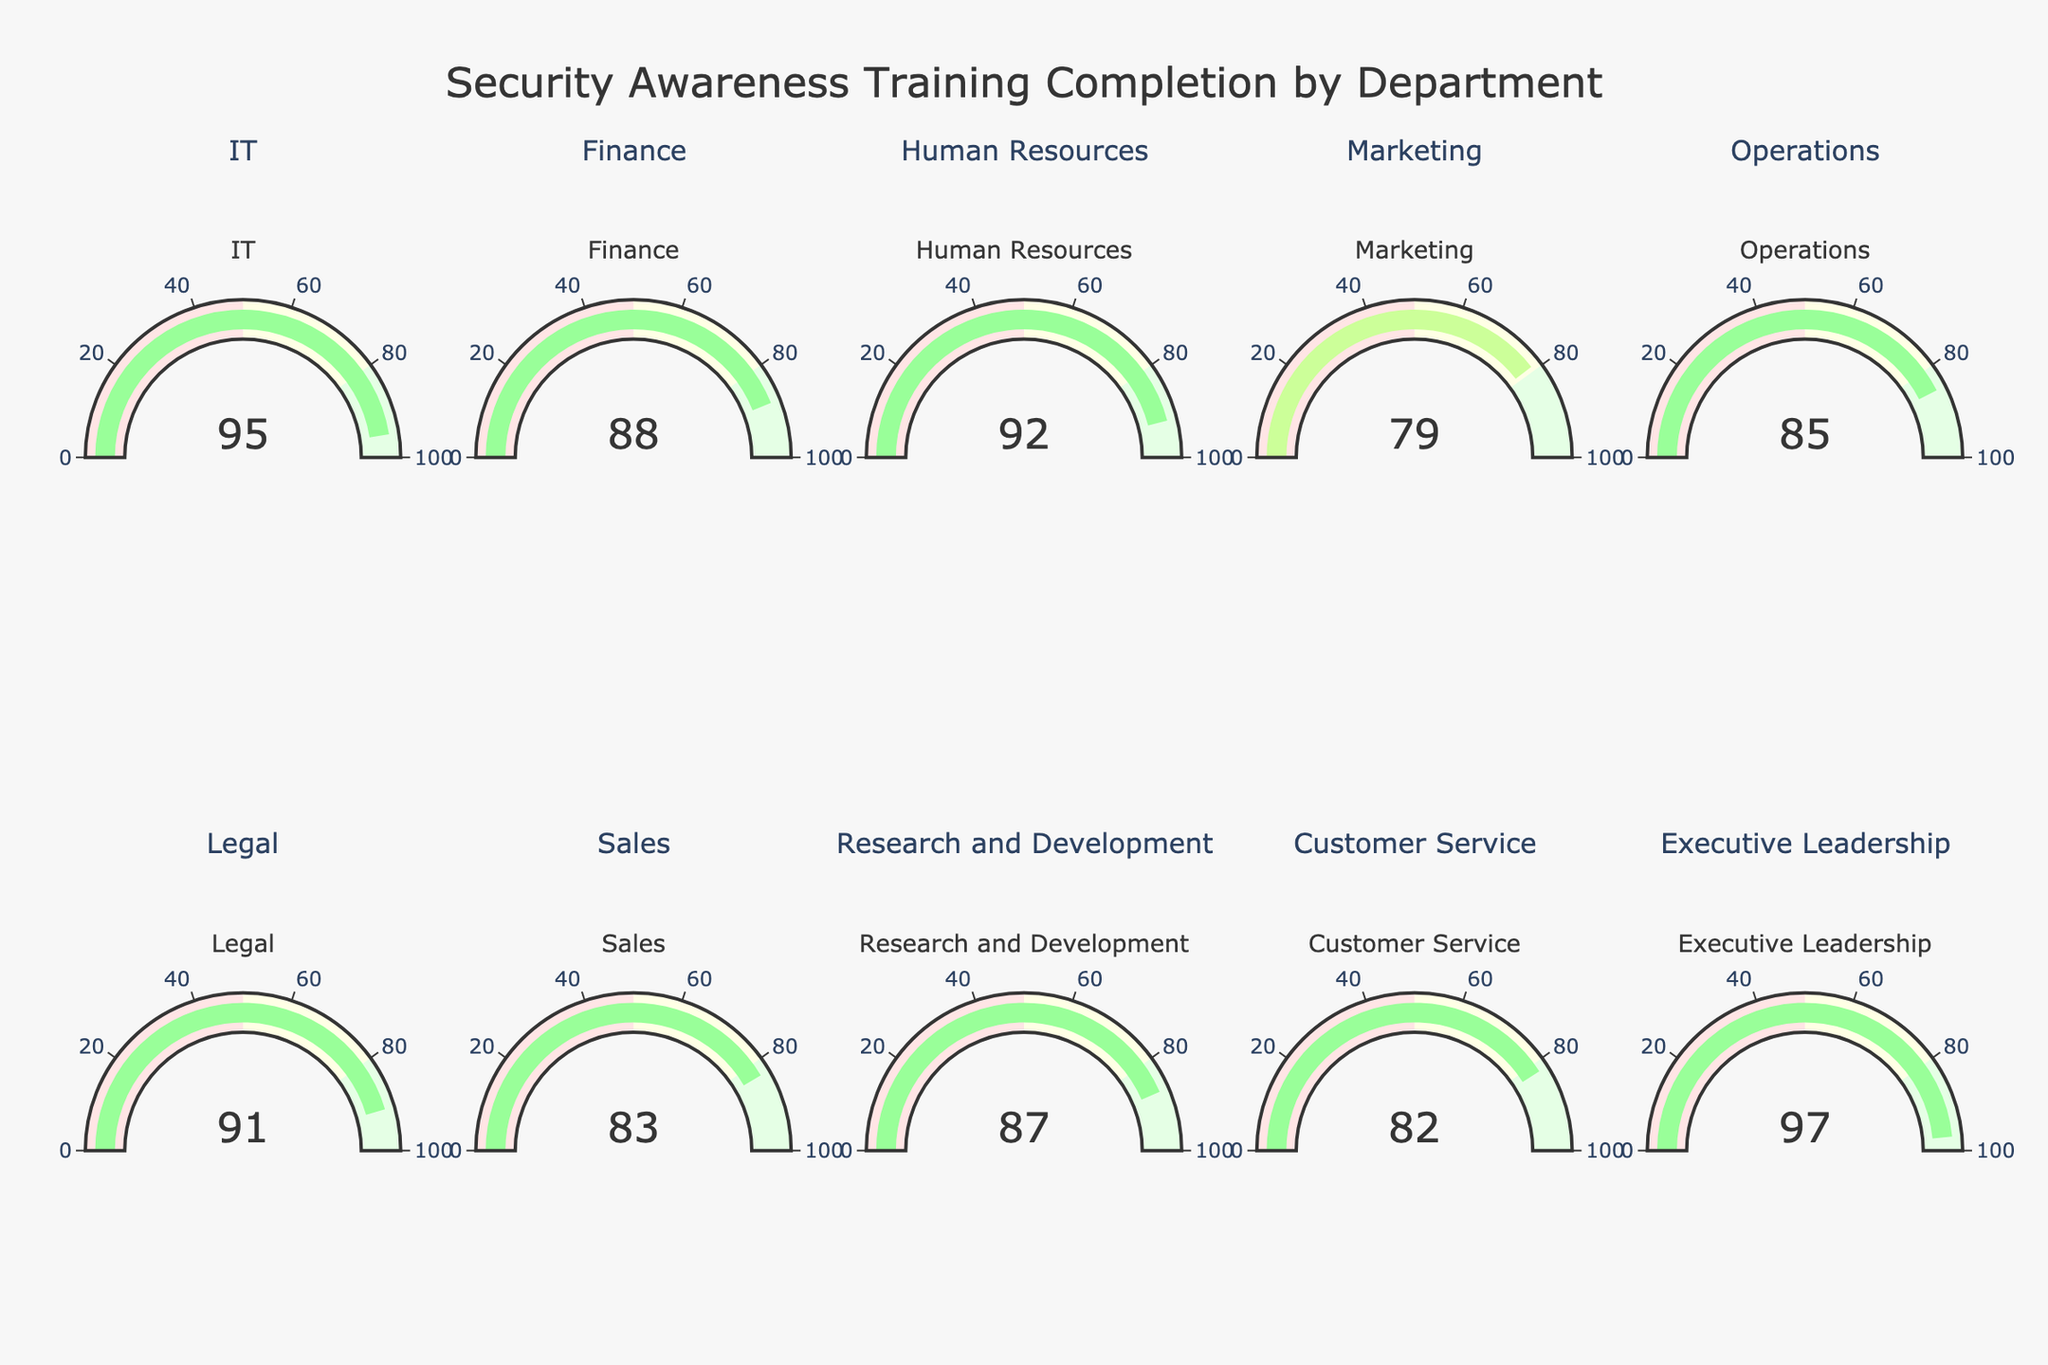Which department has the highest completion percentage? The Executive Leadership department has the highest completion percentage, indicated by a value of 97 on its gauge.
Answer: Executive Leadership Which department has the lowest completion percentage? The Marketing department has the lowest completion percentage, represented by a value of 79 on its gauge.
Answer: Marketing What is the average completion percentage across all departments? Add all the completion percentages and divide by the number of departments: (95 + 88 + 92 + 79 + 85 + 91 + 83 + 87 + 82 + 97)/10 = 879/10 = 87.9
Answer: 87.9 Which departments have a completion percentage above 90%? The departments with completion percentages above 90 are IT (95), Human Resources (92), Legal (91), and Executive Leadership (97).
Answer: IT, Human Resources, Legal, Executive Leadership How many departments have a completion percentage below 85%? The Marketing (79) and Customer Service (82) departments have completion percentages below 85%. There are 2 departments in total.
Answer: 2 What is the combined completion percentage of the Finance and Operations departments? Add the completion percentages of Finance and Operations: 88 + 85 = 173.
Answer: 173 Are more departments above or below the average completion percentage? The average completion percentage is 87.9. Departments with percentages above this average are IT (95), Human Resources (92), Legal (91), Research and Development (87), and Executive Leadership (97); those below this average are Finance (88), Marketing (79), Operations (85), Sales (83), and Customer Service (82). There are equal numbers of departments (5) above and below the average.
Answer: Equal Which gauge color range does the Sales department fall into? The Sales completion percentage is 83, falling into the yellow color range (50-80) on the gauge.
Answer: Yellow Between IT and Marketing, which department has a higher completion percentage and by how much? IT has a 95% completion rate while Marketing has 79%. To find the difference: 95 - 79 = 16.
Answer: IT by 16 What is the range of completion percentages across all departments? The completion percentages range from a minimum of 79 (Marketing) to a maximum of 97 (Executive Leadership). The range is 97 - 79 = 18.
Answer: 18 